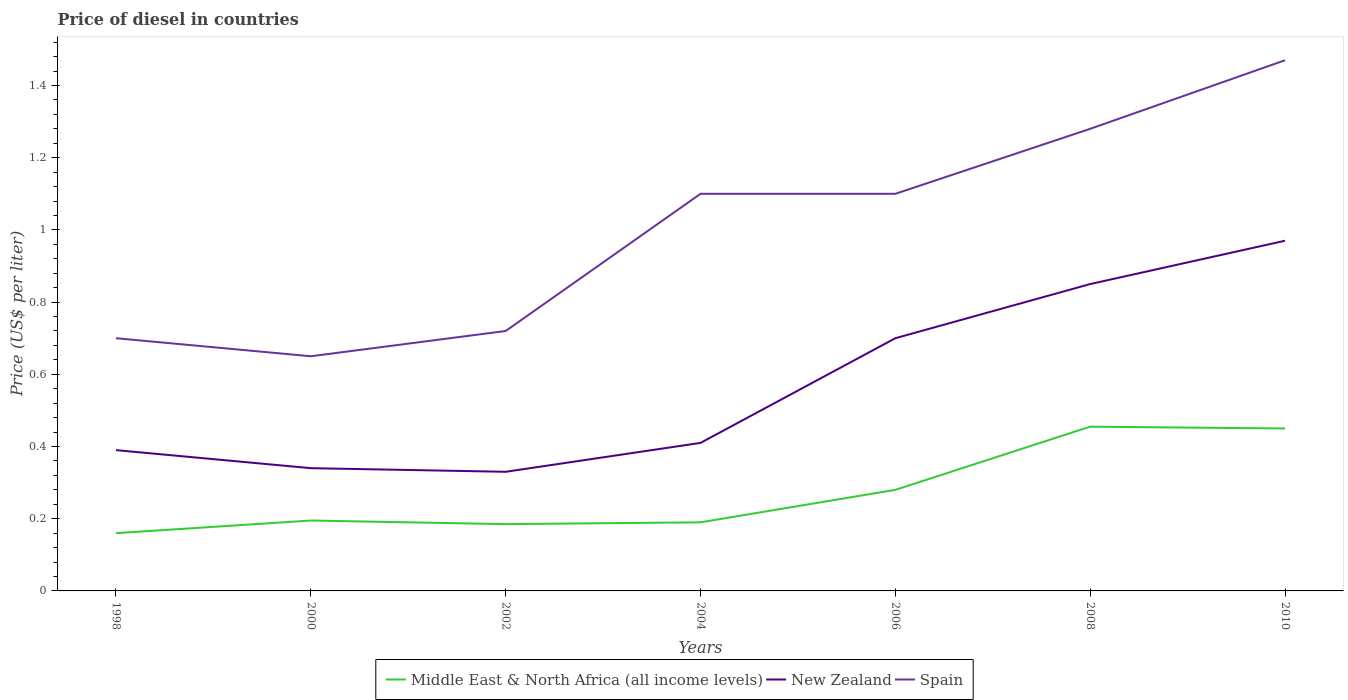How many different coloured lines are there?
Your response must be concise. 3. Is the number of lines equal to the number of legend labels?
Offer a very short reply. Yes. Across all years, what is the maximum price of diesel in Middle East & North Africa (all income levels)?
Keep it short and to the point. 0.16. In which year was the price of diesel in New Zealand maximum?
Your answer should be compact. 2002. What is the difference between the highest and the second highest price of diesel in Middle East & North Africa (all income levels)?
Provide a short and direct response. 0.3. What is the difference between the highest and the lowest price of diesel in Spain?
Offer a terse response. 4. Are the values on the major ticks of Y-axis written in scientific E-notation?
Ensure brevity in your answer.  No. Where does the legend appear in the graph?
Your response must be concise. Bottom center. How many legend labels are there?
Keep it short and to the point. 3. What is the title of the graph?
Your response must be concise. Price of diesel in countries. Does "East Asia (developing only)" appear as one of the legend labels in the graph?
Make the answer very short. No. What is the label or title of the X-axis?
Provide a short and direct response. Years. What is the label or title of the Y-axis?
Your response must be concise. Price (US$ per liter). What is the Price (US$ per liter) in Middle East & North Africa (all income levels) in 1998?
Give a very brief answer. 0.16. What is the Price (US$ per liter) of New Zealand in 1998?
Provide a short and direct response. 0.39. What is the Price (US$ per liter) in Middle East & North Africa (all income levels) in 2000?
Your response must be concise. 0.2. What is the Price (US$ per liter) in New Zealand in 2000?
Offer a very short reply. 0.34. What is the Price (US$ per liter) in Spain in 2000?
Give a very brief answer. 0.65. What is the Price (US$ per liter) of Middle East & North Africa (all income levels) in 2002?
Your answer should be compact. 0.18. What is the Price (US$ per liter) in New Zealand in 2002?
Provide a succinct answer. 0.33. What is the Price (US$ per liter) of Spain in 2002?
Your answer should be very brief. 0.72. What is the Price (US$ per liter) of Middle East & North Africa (all income levels) in 2004?
Offer a terse response. 0.19. What is the Price (US$ per liter) in New Zealand in 2004?
Offer a terse response. 0.41. What is the Price (US$ per liter) in Middle East & North Africa (all income levels) in 2006?
Ensure brevity in your answer.  0.28. What is the Price (US$ per liter) in Spain in 2006?
Provide a short and direct response. 1.1. What is the Price (US$ per liter) of Middle East & North Africa (all income levels) in 2008?
Provide a short and direct response. 0.46. What is the Price (US$ per liter) in New Zealand in 2008?
Give a very brief answer. 0.85. What is the Price (US$ per liter) in Spain in 2008?
Offer a very short reply. 1.28. What is the Price (US$ per liter) in Middle East & North Africa (all income levels) in 2010?
Offer a very short reply. 0.45. What is the Price (US$ per liter) in Spain in 2010?
Your response must be concise. 1.47. Across all years, what is the maximum Price (US$ per liter) in Middle East & North Africa (all income levels)?
Offer a terse response. 0.46. Across all years, what is the maximum Price (US$ per liter) in New Zealand?
Your answer should be compact. 0.97. Across all years, what is the maximum Price (US$ per liter) of Spain?
Offer a very short reply. 1.47. Across all years, what is the minimum Price (US$ per liter) in Middle East & North Africa (all income levels)?
Provide a short and direct response. 0.16. Across all years, what is the minimum Price (US$ per liter) in New Zealand?
Offer a terse response. 0.33. Across all years, what is the minimum Price (US$ per liter) in Spain?
Keep it short and to the point. 0.65. What is the total Price (US$ per liter) in Middle East & North Africa (all income levels) in the graph?
Offer a terse response. 1.92. What is the total Price (US$ per liter) in New Zealand in the graph?
Give a very brief answer. 3.99. What is the total Price (US$ per liter) in Spain in the graph?
Provide a succinct answer. 7.02. What is the difference between the Price (US$ per liter) of Middle East & North Africa (all income levels) in 1998 and that in 2000?
Your answer should be very brief. -0.04. What is the difference between the Price (US$ per liter) of Middle East & North Africa (all income levels) in 1998 and that in 2002?
Offer a very short reply. -0.03. What is the difference between the Price (US$ per liter) of Spain in 1998 and that in 2002?
Your answer should be very brief. -0.02. What is the difference between the Price (US$ per liter) in Middle East & North Africa (all income levels) in 1998 and that in 2004?
Ensure brevity in your answer.  -0.03. What is the difference between the Price (US$ per liter) of New Zealand in 1998 and that in 2004?
Your answer should be compact. -0.02. What is the difference between the Price (US$ per liter) of Spain in 1998 and that in 2004?
Offer a very short reply. -0.4. What is the difference between the Price (US$ per liter) in Middle East & North Africa (all income levels) in 1998 and that in 2006?
Give a very brief answer. -0.12. What is the difference between the Price (US$ per liter) of New Zealand in 1998 and that in 2006?
Provide a succinct answer. -0.31. What is the difference between the Price (US$ per liter) in Middle East & North Africa (all income levels) in 1998 and that in 2008?
Your answer should be compact. -0.29. What is the difference between the Price (US$ per liter) in New Zealand in 1998 and that in 2008?
Give a very brief answer. -0.46. What is the difference between the Price (US$ per liter) of Spain in 1998 and that in 2008?
Make the answer very short. -0.58. What is the difference between the Price (US$ per liter) in Middle East & North Africa (all income levels) in 1998 and that in 2010?
Provide a short and direct response. -0.29. What is the difference between the Price (US$ per liter) in New Zealand in 1998 and that in 2010?
Ensure brevity in your answer.  -0.58. What is the difference between the Price (US$ per liter) in Spain in 1998 and that in 2010?
Your answer should be very brief. -0.77. What is the difference between the Price (US$ per liter) in Spain in 2000 and that in 2002?
Your response must be concise. -0.07. What is the difference between the Price (US$ per liter) of Middle East & North Africa (all income levels) in 2000 and that in 2004?
Ensure brevity in your answer.  0.01. What is the difference between the Price (US$ per liter) in New Zealand in 2000 and that in 2004?
Your response must be concise. -0.07. What is the difference between the Price (US$ per liter) in Spain in 2000 and that in 2004?
Ensure brevity in your answer.  -0.45. What is the difference between the Price (US$ per liter) in Middle East & North Africa (all income levels) in 2000 and that in 2006?
Make the answer very short. -0.09. What is the difference between the Price (US$ per liter) in New Zealand in 2000 and that in 2006?
Give a very brief answer. -0.36. What is the difference between the Price (US$ per liter) in Spain in 2000 and that in 2006?
Offer a very short reply. -0.45. What is the difference between the Price (US$ per liter) of Middle East & North Africa (all income levels) in 2000 and that in 2008?
Keep it short and to the point. -0.26. What is the difference between the Price (US$ per liter) of New Zealand in 2000 and that in 2008?
Keep it short and to the point. -0.51. What is the difference between the Price (US$ per liter) in Spain in 2000 and that in 2008?
Offer a very short reply. -0.63. What is the difference between the Price (US$ per liter) of Middle East & North Africa (all income levels) in 2000 and that in 2010?
Make the answer very short. -0.26. What is the difference between the Price (US$ per liter) in New Zealand in 2000 and that in 2010?
Give a very brief answer. -0.63. What is the difference between the Price (US$ per liter) of Spain in 2000 and that in 2010?
Offer a very short reply. -0.82. What is the difference between the Price (US$ per liter) in Middle East & North Africa (all income levels) in 2002 and that in 2004?
Your answer should be very brief. -0.01. What is the difference between the Price (US$ per liter) in New Zealand in 2002 and that in 2004?
Offer a very short reply. -0.08. What is the difference between the Price (US$ per liter) in Spain in 2002 and that in 2004?
Provide a short and direct response. -0.38. What is the difference between the Price (US$ per liter) of Middle East & North Africa (all income levels) in 2002 and that in 2006?
Your response must be concise. -0.1. What is the difference between the Price (US$ per liter) of New Zealand in 2002 and that in 2006?
Offer a terse response. -0.37. What is the difference between the Price (US$ per liter) in Spain in 2002 and that in 2006?
Offer a terse response. -0.38. What is the difference between the Price (US$ per liter) in Middle East & North Africa (all income levels) in 2002 and that in 2008?
Your answer should be very brief. -0.27. What is the difference between the Price (US$ per liter) of New Zealand in 2002 and that in 2008?
Make the answer very short. -0.52. What is the difference between the Price (US$ per liter) in Spain in 2002 and that in 2008?
Provide a succinct answer. -0.56. What is the difference between the Price (US$ per liter) in Middle East & North Africa (all income levels) in 2002 and that in 2010?
Make the answer very short. -0.27. What is the difference between the Price (US$ per liter) of New Zealand in 2002 and that in 2010?
Keep it short and to the point. -0.64. What is the difference between the Price (US$ per liter) of Spain in 2002 and that in 2010?
Keep it short and to the point. -0.75. What is the difference between the Price (US$ per liter) in Middle East & North Africa (all income levels) in 2004 and that in 2006?
Ensure brevity in your answer.  -0.09. What is the difference between the Price (US$ per liter) of New Zealand in 2004 and that in 2006?
Offer a very short reply. -0.29. What is the difference between the Price (US$ per liter) of Middle East & North Africa (all income levels) in 2004 and that in 2008?
Provide a short and direct response. -0.27. What is the difference between the Price (US$ per liter) in New Zealand in 2004 and that in 2008?
Offer a terse response. -0.44. What is the difference between the Price (US$ per liter) in Spain in 2004 and that in 2008?
Offer a terse response. -0.18. What is the difference between the Price (US$ per liter) in Middle East & North Africa (all income levels) in 2004 and that in 2010?
Give a very brief answer. -0.26. What is the difference between the Price (US$ per liter) of New Zealand in 2004 and that in 2010?
Ensure brevity in your answer.  -0.56. What is the difference between the Price (US$ per liter) in Spain in 2004 and that in 2010?
Offer a terse response. -0.37. What is the difference between the Price (US$ per liter) in Middle East & North Africa (all income levels) in 2006 and that in 2008?
Give a very brief answer. -0.17. What is the difference between the Price (US$ per liter) of Spain in 2006 and that in 2008?
Your answer should be very brief. -0.18. What is the difference between the Price (US$ per liter) of Middle East & North Africa (all income levels) in 2006 and that in 2010?
Your answer should be compact. -0.17. What is the difference between the Price (US$ per liter) of New Zealand in 2006 and that in 2010?
Keep it short and to the point. -0.27. What is the difference between the Price (US$ per liter) in Spain in 2006 and that in 2010?
Make the answer very short. -0.37. What is the difference between the Price (US$ per liter) in Middle East & North Africa (all income levels) in 2008 and that in 2010?
Offer a terse response. 0.01. What is the difference between the Price (US$ per liter) in New Zealand in 2008 and that in 2010?
Provide a succinct answer. -0.12. What is the difference between the Price (US$ per liter) of Spain in 2008 and that in 2010?
Your answer should be very brief. -0.19. What is the difference between the Price (US$ per liter) in Middle East & North Africa (all income levels) in 1998 and the Price (US$ per liter) in New Zealand in 2000?
Keep it short and to the point. -0.18. What is the difference between the Price (US$ per liter) of Middle East & North Africa (all income levels) in 1998 and the Price (US$ per liter) of Spain in 2000?
Provide a short and direct response. -0.49. What is the difference between the Price (US$ per liter) of New Zealand in 1998 and the Price (US$ per liter) of Spain in 2000?
Give a very brief answer. -0.26. What is the difference between the Price (US$ per liter) of Middle East & North Africa (all income levels) in 1998 and the Price (US$ per liter) of New Zealand in 2002?
Provide a short and direct response. -0.17. What is the difference between the Price (US$ per liter) of Middle East & North Africa (all income levels) in 1998 and the Price (US$ per liter) of Spain in 2002?
Ensure brevity in your answer.  -0.56. What is the difference between the Price (US$ per liter) in New Zealand in 1998 and the Price (US$ per liter) in Spain in 2002?
Your answer should be very brief. -0.33. What is the difference between the Price (US$ per liter) in Middle East & North Africa (all income levels) in 1998 and the Price (US$ per liter) in New Zealand in 2004?
Offer a very short reply. -0.25. What is the difference between the Price (US$ per liter) of Middle East & North Africa (all income levels) in 1998 and the Price (US$ per liter) of Spain in 2004?
Provide a succinct answer. -0.94. What is the difference between the Price (US$ per liter) in New Zealand in 1998 and the Price (US$ per liter) in Spain in 2004?
Make the answer very short. -0.71. What is the difference between the Price (US$ per liter) in Middle East & North Africa (all income levels) in 1998 and the Price (US$ per liter) in New Zealand in 2006?
Give a very brief answer. -0.54. What is the difference between the Price (US$ per liter) of Middle East & North Africa (all income levels) in 1998 and the Price (US$ per liter) of Spain in 2006?
Offer a terse response. -0.94. What is the difference between the Price (US$ per liter) of New Zealand in 1998 and the Price (US$ per liter) of Spain in 2006?
Provide a succinct answer. -0.71. What is the difference between the Price (US$ per liter) of Middle East & North Africa (all income levels) in 1998 and the Price (US$ per liter) of New Zealand in 2008?
Keep it short and to the point. -0.69. What is the difference between the Price (US$ per liter) of Middle East & North Africa (all income levels) in 1998 and the Price (US$ per liter) of Spain in 2008?
Offer a terse response. -1.12. What is the difference between the Price (US$ per liter) in New Zealand in 1998 and the Price (US$ per liter) in Spain in 2008?
Offer a terse response. -0.89. What is the difference between the Price (US$ per liter) of Middle East & North Africa (all income levels) in 1998 and the Price (US$ per liter) of New Zealand in 2010?
Offer a very short reply. -0.81. What is the difference between the Price (US$ per liter) of Middle East & North Africa (all income levels) in 1998 and the Price (US$ per liter) of Spain in 2010?
Your answer should be compact. -1.31. What is the difference between the Price (US$ per liter) of New Zealand in 1998 and the Price (US$ per liter) of Spain in 2010?
Give a very brief answer. -1.08. What is the difference between the Price (US$ per liter) of Middle East & North Africa (all income levels) in 2000 and the Price (US$ per liter) of New Zealand in 2002?
Ensure brevity in your answer.  -0.14. What is the difference between the Price (US$ per liter) in Middle East & North Africa (all income levels) in 2000 and the Price (US$ per liter) in Spain in 2002?
Offer a very short reply. -0.53. What is the difference between the Price (US$ per liter) in New Zealand in 2000 and the Price (US$ per liter) in Spain in 2002?
Keep it short and to the point. -0.38. What is the difference between the Price (US$ per liter) of Middle East & North Africa (all income levels) in 2000 and the Price (US$ per liter) of New Zealand in 2004?
Your answer should be compact. -0.21. What is the difference between the Price (US$ per liter) of Middle East & North Africa (all income levels) in 2000 and the Price (US$ per liter) of Spain in 2004?
Keep it short and to the point. -0.91. What is the difference between the Price (US$ per liter) of New Zealand in 2000 and the Price (US$ per liter) of Spain in 2004?
Give a very brief answer. -0.76. What is the difference between the Price (US$ per liter) in Middle East & North Africa (all income levels) in 2000 and the Price (US$ per liter) in New Zealand in 2006?
Your response must be concise. -0.51. What is the difference between the Price (US$ per liter) of Middle East & North Africa (all income levels) in 2000 and the Price (US$ per liter) of Spain in 2006?
Your response must be concise. -0.91. What is the difference between the Price (US$ per liter) of New Zealand in 2000 and the Price (US$ per liter) of Spain in 2006?
Your answer should be very brief. -0.76. What is the difference between the Price (US$ per liter) of Middle East & North Africa (all income levels) in 2000 and the Price (US$ per liter) of New Zealand in 2008?
Offer a very short reply. -0.66. What is the difference between the Price (US$ per liter) of Middle East & North Africa (all income levels) in 2000 and the Price (US$ per liter) of Spain in 2008?
Give a very brief answer. -1.08. What is the difference between the Price (US$ per liter) in New Zealand in 2000 and the Price (US$ per liter) in Spain in 2008?
Your answer should be very brief. -0.94. What is the difference between the Price (US$ per liter) of Middle East & North Africa (all income levels) in 2000 and the Price (US$ per liter) of New Zealand in 2010?
Offer a very short reply. -0.78. What is the difference between the Price (US$ per liter) of Middle East & North Africa (all income levels) in 2000 and the Price (US$ per liter) of Spain in 2010?
Keep it short and to the point. -1.27. What is the difference between the Price (US$ per liter) in New Zealand in 2000 and the Price (US$ per liter) in Spain in 2010?
Provide a succinct answer. -1.13. What is the difference between the Price (US$ per liter) in Middle East & North Africa (all income levels) in 2002 and the Price (US$ per liter) in New Zealand in 2004?
Offer a terse response. -0.23. What is the difference between the Price (US$ per liter) of Middle East & North Africa (all income levels) in 2002 and the Price (US$ per liter) of Spain in 2004?
Give a very brief answer. -0.92. What is the difference between the Price (US$ per liter) in New Zealand in 2002 and the Price (US$ per liter) in Spain in 2004?
Your answer should be very brief. -0.77. What is the difference between the Price (US$ per liter) in Middle East & North Africa (all income levels) in 2002 and the Price (US$ per liter) in New Zealand in 2006?
Keep it short and to the point. -0.52. What is the difference between the Price (US$ per liter) in Middle East & North Africa (all income levels) in 2002 and the Price (US$ per liter) in Spain in 2006?
Your answer should be compact. -0.92. What is the difference between the Price (US$ per liter) in New Zealand in 2002 and the Price (US$ per liter) in Spain in 2006?
Make the answer very short. -0.77. What is the difference between the Price (US$ per liter) in Middle East & North Africa (all income levels) in 2002 and the Price (US$ per liter) in New Zealand in 2008?
Your answer should be very brief. -0.67. What is the difference between the Price (US$ per liter) of Middle East & North Africa (all income levels) in 2002 and the Price (US$ per liter) of Spain in 2008?
Your response must be concise. -1.09. What is the difference between the Price (US$ per liter) in New Zealand in 2002 and the Price (US$ per liter) in Spain in 2008?
Offer a very short reply. -0.95. What is the difference between the Price (US$ per liter) of Middle East & North Africa (all income levels) in 2002 and the Price (US$ per liter) of New Zealand in 2010?
Your response must be concise. -0.79. What is the difference between the Price (US$ per liter) of Middle East & North Africa (all income levels) in 2002 and the Price (US$ per liter) of Spain in 2010?
Your answer should be very brief. -1.28. What is the difference between the Price (US$ per liter) in New Zealand in 2002 and the Price (US$ per liter) in Spain in 2010?
Provide a short and direct response. -1.14. What is the difference between the Price (US$ per liter) of Middle East & North Africa (all income levels) in 2004 and the Price (US$ per liter) of New Zealand in 2006?
Provide a succinct answer. -0.51. What is the difference between the Price (US$ per liter) of Middle East & North Africa (all income levels) in 2004 and the Price (US$ per liter) of Spain in 2006?
Offer a terse response. -0.91. What is the difference between the Price (US$ per liter) in New Zealand in 2004 and the Price (US$ per liter) in Spain in 2006?
Keep it short and to the point. -0.69. What is the difference between the Price (US$ per liter) in Middle East & North Africa (all income levels) in 2004 and the Price (US$ per liter) in New Zealand in 2008?
Provide a short and direct response. -0.66. What is the difference between the Price (US$ per liter) in Middle East & North Africa (all income levels) in 2004 and the Price (US$ per liter) in Spain in 2008?
Ensure brevity in your answer.  -1.09. What is the difference between the Price (US$ per liter) of New Zealand in 2004 and the Price (US$ per liter) of Spain in 2008?
Ensure brevity in your answer.  -0.87. What is the difference between the Price (US$ per liter) of Middle East & North Africa (all income levels) in 2004 and the Price (US$ per liter) of New Zealand in 2010?
Keep it short and to the point. -0.78. What is the difference between the Price (US$ per liter) in Middle East & North Africa (all income levels) in 2004 and the Price (US$ per liter) in Spain in 2010?
Your answer should be compact. -1.28. What is the difference between the Price (US$ per liter) of New Zealand in 2004 and the Price (US$ per liter) of Spain in 2010?
Make the answer very short. -1.06. What is the difference between the Price (US$ per liter) in Middle East & North Africa (all income levels) in 2006 and the Price (US$ per liter) in New Zealand in 2008?
Ensure brevity in your answer.  -0.57. What is the difference between the Price (US$ per liter) in Middle East & North Africa (all income levels) in 2006 and the Price (US$ per liter) in Spain in 2008?
Offer a terse response. -1. What is the difference between the Price (US$ per liter) of New Zealand in 2006 and the Price (US$ per liter) of Spain in 2008?
Provide a succinct answer. -0.58. What is the difference between the Price (US$ per liter) in Middle East & North Africa (all income levels) in 2006 and the Price (US$ per liter) in New Zealand in 2010?
Your answer should be compact. -0.69. What is the difference between the Price (US$ per liter) of Middle East & North Africa (all income levels) in 2006 and the Price (US$ per liter) of Spain in 2010?
Keep it short and to the point. -1.19. What is the difference between the Price (US$ per liter) of New Zealand in 2006 and the Price (US$ per liter) of Spain in 2010?
Provide a short and direct response. -0.77. What is the difference between the Price (US$ per liter) in Middle East & North Africa (all income levels) in 2008 and the Price (US$ per liter) in New Zealand in 2010?
Your answer should be compact. -0.52. What is the difference between the Price (US$ per liter) of Middle East & North Africa (all income levels) in 2008 and the Price (US$ per liter) of Spain in 2010?
Offer a terse response. -1.01. What is the difference between the Price (US$ per liter) in New Zealand in 2008 and the Price (US$ per liter) in Spain in 2010?
Your response must be concise. -0.62. What is the average Price (US$ per liter) of Middle East & North Africa (all income levels) per year?
Your answer should be very brief. 0.27. What is the average Price (US$ per liter) of New Zealand per year?
Provide a short and direct response. 0.57. In the year 1998, what is the difference between the Price (US$ per liter) of Middle East & North Africa (all income levels) and Price (US$ per liter) of New Zealand?
Your response must be concise. -0.23. In the year 1998, what is the difference between the Price (US$ per liter) of Middle East & North Africa (all income levels) and Price (US$ per liter) of Spain?
Give a very brief answer. -0.54. In the year 1998, what is the difference between the Price (US$ per liter) of New Zealand and Price (US$ per liter) of Spain?
Your response must be concise. -0.31. In the year 2000, what is the difference between the Price (US$ per liter) of Middle East & North Africa (all income levels) and Price (US$ per liter) of New Zealand?
Ensure brevity in your answer.  -0.14. In the year 2000, what is the difference between the Price (US$ per liter) of Middle East & North Africa (all income levels) and Price (US$ per liter) of Spain?
Ensure brevity in your answer.  -0.46. In the year 2000, what is the difference between the Price (US$ per liter) of New Zealand and Price (US$ per liter) of Spain?
Offer a terse response. -0.31. In the year 2002, what is the difference between the Price (US$ per liter) in Middle East & North Africa (all income levels) and Price (US$ per liter) in New Zealand?
Keep it short and to the point. -0.14. In the year 2002, what is the difference between the Price (US$ per liter) of Middle East & North Africa (all income levels) and Price (US$ per liter) of Spain?
Your answer should be very brief. -0.54. In the year 2002, what is the difference between the Price (US$ per liter) of New Zealand and Price (US$ per liter) of Spain?
Make the answer very short. -0.39. In the year 2004, what is the difference between the Price (US$ per liter) in Middle East & North Africa (all income levels) and Price (US$ per liter) in New Zealand?
Keep it short and to the point. -0.22. In the year 2004, what is the difference between the Price (US$ per liter) of Middle East & North Africa (all income levels) and Price (US$ per liter) of Spain?
Your answer should be compact. -0.91. In the year 2004, what is the difference between the Price (US$ per liter) of New Zealand and Price (US$ per liter) of Spain?
Offer a terse response. -0.69. In the year 2006, what is the difference between the Price (US$ per liter) in Middle East & North Africa (all income levels) and Price (US$ per liter) in New Zealand?
Your response must be concise. -0.42. In the year 2006, what is the difference between the Price (US$ per liter) in Middle East & North Africa (all income levels) and Price (US$ per liter) in Spain?
Make the answer very short. -0.82. In the year 2006, what is the difference between the Price (US$ per liter) in New Zealand and Price (US$ per liter) in Spain?
Your response must be concise. -0.4. In the year 2008, what is the difference between the Price (US$ per liter) in Middle East & North Africa (all income levels) and Price (US$ per liter) in New Zealand?
Your answer should be compact. -0.4. In the year 2008, what is the difference between the Price (US$ per liter) of Middle East & North Africa (all income levels) and Price (US$ per liter) of Spain?
Offer a very short reply. -0.82. In the year 2008, what is the difference between the Price (US$ per liter) in New Zealand and Price (US$ per liter) in Spain?
Keep it short and to the point. -0.43. In the year 2010, what is the difference between the Price (US$ per liter) of Middle East & North Africa (all income levels) and Price (US$ per liter) of New Zealand?
Give a very brief answer. -0.52. In the year 2010, what is the difference between the Price (US$ per liter) of Middle East & North Africa (all income levels) and Price (US$ per liter) of Spain?
Your answer should be very brief. -1.02. What is the ratio of the Price (US$ per liter) of Middle East & North Africa (all income levels) in 1998 to that in 2000?
Your answer should be compact. 0.82. What is the ratio of the Price (US$ per liter) in New Zealand in 1998 to that in 2000?
Offer a terse response. 1.15. What is the ratio of the Price (US$ per liter) of Middle East & North Africa (all income levels) in 1998 to that in 2002?
Your answer should be very brief. 0.86. What is the ratio of the Price (US$ per liter) in New Zealand in 1998 to that in 2002?
Make the answer very short. 1.18. What is the ratio of the Price (US$ per liter) in Spain in 1998 to that in 2002?
Give a very brief answer. 0.97. What is the ratio of the Price (US$ per liter) of Middle East & North Africa (all income levels) in 1998 to that in 2004?
Your answer should be compact. 0.84. What is the ratio of the Price (US$ per liter) in New Zealand in 1998 to that in 2004?
Keep it short and to the point. 0.95. What is the ratio of the Price (US$ per liter) in Spain in 1998 to that in 2004?
Provide a short and direct response. 0.64. What is the ratio of the Price (US$ per liter) in New Zealand in 1998 to that in 2006?
Provide a short and direct response. 0.56. What is the ratio of the Price (US$ per liter) of Spain in 1998 to that in 2006?
Your answer should be compact. 0.64. What is the ratio of the Price (US$ per liter) in Middle East & North Africa (all income levels) in 1998 to that in 2008?
Your response must be concise. 0.35. What is the ratio of the Price (US$ per liter) of New Zealand in 1998 to that in 2008?
Your answer should be very brief. 0.46. What is the ratio of the Price (US$ per liter) in Spain in 1998 to that in 2008?
Your response must be concise. 0.55. What is the ratio of the Price (US$ per liter) in Middle East & North Africa (all income levels) in 1998 to that in 2010?
Offer a very short reply. 0.36. What is the ratio of the Price (US$ per liter) of New Zealand in 1998 to that in 2010?
Your answer should be compact. 0.4. What is the ratio of the Price (US$ per liter) of Spain in 1998 to that in 2010?
Give a very brief answer. 0.48. What is the ratio of the Price (US$ per liter) of Middle East & North Africa (all income levels) in 2000 to that in 2002?
Provide a short and direct response. 1.05. What is the ratio of the Price (US$ per liter) in New Zealand in 2000 to that in 2002?
Your answer should be very brief. 1.03. What is the ratio of the Price (US$ per liter) in Spain in 2000 to that in 2002?
Ensure brevity in your answer.  0.9. What is the ratio of the Price (US$ per liter) in Middle East & North Africa (all income levels) in 2000 to that in 2004?
Ensure brevity in your answer.  1.03. What is the ratio of the Price (US$ per liter) of New Zealand in 2000 to that in 2004?
Your response must be concise. 0.83. What is the ratio of the Price (US$ per liter) in Spain in 2000 to that in 2004?
Your response must be concise. 0.59. What is the ratio of the Price (US$ per liter) in Middle East & North Africa (all income levels) in 2000 to that in 2006?
Provide a succinct answer. 0.7. What is the ratio of the Price (US$ per liter) in New Zealand in 2000 to that in 2006?
Your response must be concise. 0.49. What is the ratio of the Price (US$ per liter) of Spain in 2000 to that in 2006?
Provide a short and direct response. 0.59. What is the ratio of the Price (US$ per liter) of Middle East & North Africa (all income levels) in 2000 to that in 2008?
Your response must be concise. 0.43. What is the ratio of the Price (US$ per liter) in Spain in 2000 to that in 2008?
Offer a very short reply. 0.51. What is the ratio of the Price (US$ per liter) in Middle East & North Africa (all income levels) in 2000 to that in 2010?
Give a very brief answer. 0.43. What is the ratio of the Price (US$ per liter) of New Zealand in 2000 to that in 2010?
Offer a terse response. 0.35. What is the ratio of the Price (US$ per liter) in Spain in 2000 to that in 2010?
Make the answer very short. 0.44. What is the ratio of the Price (US$ per liter) of Middle East & North Africa (all income levels) in 2002 to that in 2004?
Keep it short and to the point. 0.97. What is the ratio of the Price (US$ per liter) of New Zealand in 2002 to that in 2004?
Ensure brevity in your answer.  0.8. What is the ratio of the Price (US$ per liter) in Spain in 2002 to that in 2004?
Your answer should be compact. 0.65. What is the ratio of the Price (US$ per liter) of Middle East & North Africa (all income levels) in 2002 to that in 2006?
Give a very brief answer. 0.66. What is the ratio of the Price (US$ per liter) of New Zealand in 2002 to that in 2006?
Your answer should be very brief. 0.47. What is the ratio of the Price (US$ per liter) of Spain in 2002 to that in 2006?
Provide a short and direct response. 0.65. What is the ratio of the Price (US$ per liter) in Middle East & North Africa (all income levels) in 2002 to that in 2008?
Give a very brief answer. 0.41. What is the ratio of the Price (US$ per liter) of New Zealand in 2002 to that in 2008?
Your answer should be very brief. 0.39. What is the ratio of the Price (US$ per liter) of Spain in 2002 to that in 2008?
Offer a terse response. 0.56. What is the ratio of the Price (US$ per liter) in Middle East & North Africa (all income levels) in 2002 to that in 2010?
Ensure brevity in your answer.  0.41. What is the ratio of the Price (US$ per liter) in New Zealand in 2002 to that in 2010?
Offer a terse response. 0.34. What is the ratio of the Price (US$ per liter) in Spain in 2002 to that in 2010?
Offer a terse response. 0.49. What is the ratio of the Price (US$ per liter) of Middle East & North Africa (all income levels) in 2004 to that in 2006?
Give a very brief answer. 0.68. What is the ratio of the Price (US$ per liter) in New Zealand in 2004 to that in 2006?
Provide a short and direct response. 0.59. What is the ratio of the Price (US$ per liter) of Middle East & North Africa (all income levels) in 2004 to that in 2008?
Your answer should be compact. 0.42. What is the ratio of the Price (US$ per liter) in New Zealand in 2004 to that in 2008?
Your response must be concise. 0.48. What is the ratio of the Price (US$ per liter) of Spain in 2004 to that in 2008?
Your response must be concise. 0.86. What is the ratio of the Price (US$ per liter) in Middle East & North Africa (all income levels) in 2004 to that in 2010?
Keep it short and to the point. 0.42. What is the ratio of the Price (US$ per liter) in New Zealand in 2004 to that in 2010?
Your answer should be compact. 0.42. What is the ratio of the Price (US$ per liter) in Spain in 2004 to that in 2010?
Ensure brevity in your answer.  0.75. What is the ratio of the Price (US$ per liter) in Middle East & North Africa (all income levels) in 2006 to that in 2008?
Provide a succinct answer. 0.62. What is the ratio of the Price (US$ per liter) in New Zealand in 2006 to that in 2008?
Your response must be concise. 0.82. What is the ratio of the Price (US$ per liter) in Spain in 2006 to that in 2008?
Your answer should be very brief. 0.86. What is the ratio of the Price (US$ per liter) of Middle East & North Africa (all income levels) in 2006 to that in 2010?
Make the answer very short. 0.62. What is the ratio of the Price (US$ per liter) in New Zealand in 2006 to that in 2010?
Provide a short and direct response. 0.72. What is the ratio of the Price (US$ per liter) in Spain in 2006 to that in 2010?
Provide a succinct answer. 0.75. What is the ratio of the Price (US$ per liter) in Middle East & North Africa (all income levels) in 2008 to that in 2010?
Provide a short and direct response. 1.01. What is the ratio of the Price (US$ per liter) in New Zealand in 2008 to that in 2010?
Keep it short and to the point. 0.88. What is the ratio of the Price (US$ per liter) of Spain in 2008 to that in 2010?
Make the answer very short. 0.87. What is the difference between the highest and the second highest Price (US$ per liter) in Middle East & North Africa (all income levels)?
Your response must be concise. 0.01. What is the difference between the highest and the second highest Price (US$ per liter) in New Zealand?
Your answer should be very brief. 0.12. What is the difference between the highest and the second highest Price (US$ per liter) of Spain?
Keep it short and to the point. 0.19. What is the difference between the highest and the lowest Price (US$ per liter) in Middle East & North Africa (all income levels)?
Your answer should be compact. 0.29. What is the difference between the highest and the lowest Price (US$ per liter) of New Zealand?
Your answer should be compact. 0.64. What is the difference between the highest and the lowest Price (US$ per liter) in Spain?
Keep it short and to the point. 0.82. 